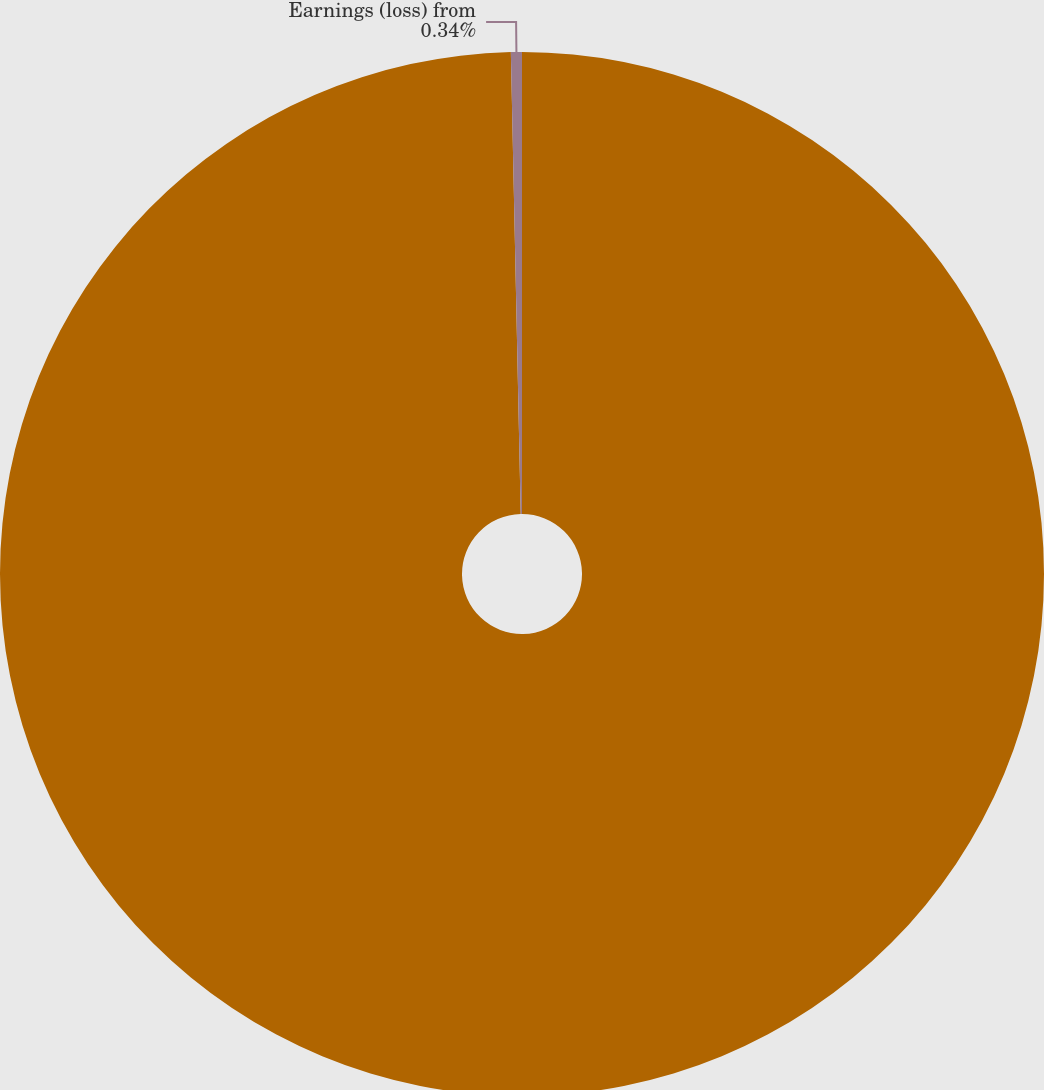<chart> <loc_0><loc_0><loc_500><loc_500><pie_chart><fcel>Net revenue<fcel>Earnings (loss) from<nl><fcel>99.66%<fcel>0.34%<nl></chart> 